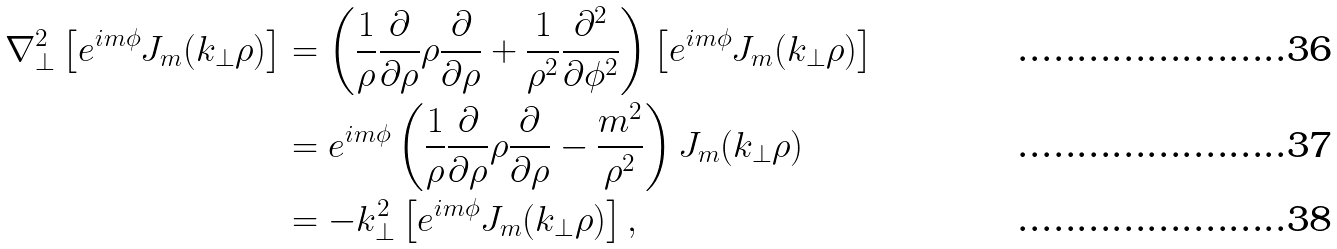Convert formula to latex. <formula><loc_0><loc_0><loc_500><loc_500>\nabla _ { \perp } ^ { 2 } \left [ e ^ { i m \phi } J _ { m } ( k _ { \perp } \rho ) \right ] & = \left ( \frac { 1 } { \rho } \frac { \partial } { \partial \rho } \rho \frac { \partial } { \partial \rho } + \frac { 1 } { \rho ^ { 2 } } \frac { \partial ^ { 2 } } { \partial \phi ^ { 2 } } \right ) \left [ e ^ { i m \phi } J _ { m } ( k _ { \perp } \rho ) \right ] \\ & = e ^ { i m \phi } \left ( \frac { 1 } { \rho } \frac { \partial } { \partial \rho } \rho \frac { \partial } { \partial \rho } - \frac { m ^ { 2 } } { \rho ^ { 2 } } \right ) J _ { m } ( k _ { \perp } \rho ) \\ & = - k _ { \perp } ^ { 2 } \left [ e ^ { i m \phi } J _ { m } ( k _ { \perp } \rho ) \right ] ,</formula> 